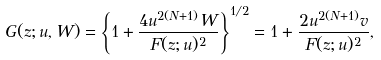<formula> <loc_0><loc_0><loc_500><loc_500>G ( z ; u , W ) = \left \{ 1 + \frac { 4 u ^ { 2 ( N + 1 ) } W } { F ( z ; u ) ^ { 2 } } \right \} ^ { 1 / 2 } = 1 + \frac { 2 u ^ { 2 ( N + 1 ) } v } { F ( z ; u ) ^ { 2 } } ,</formula> 